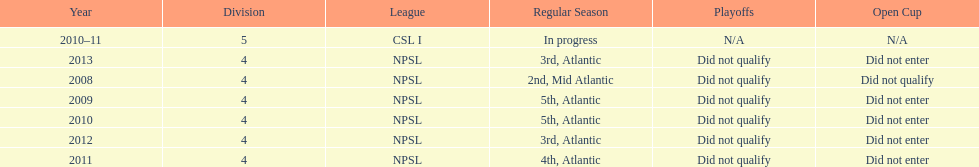How many 3rd place finishes has npsl had? 2. 